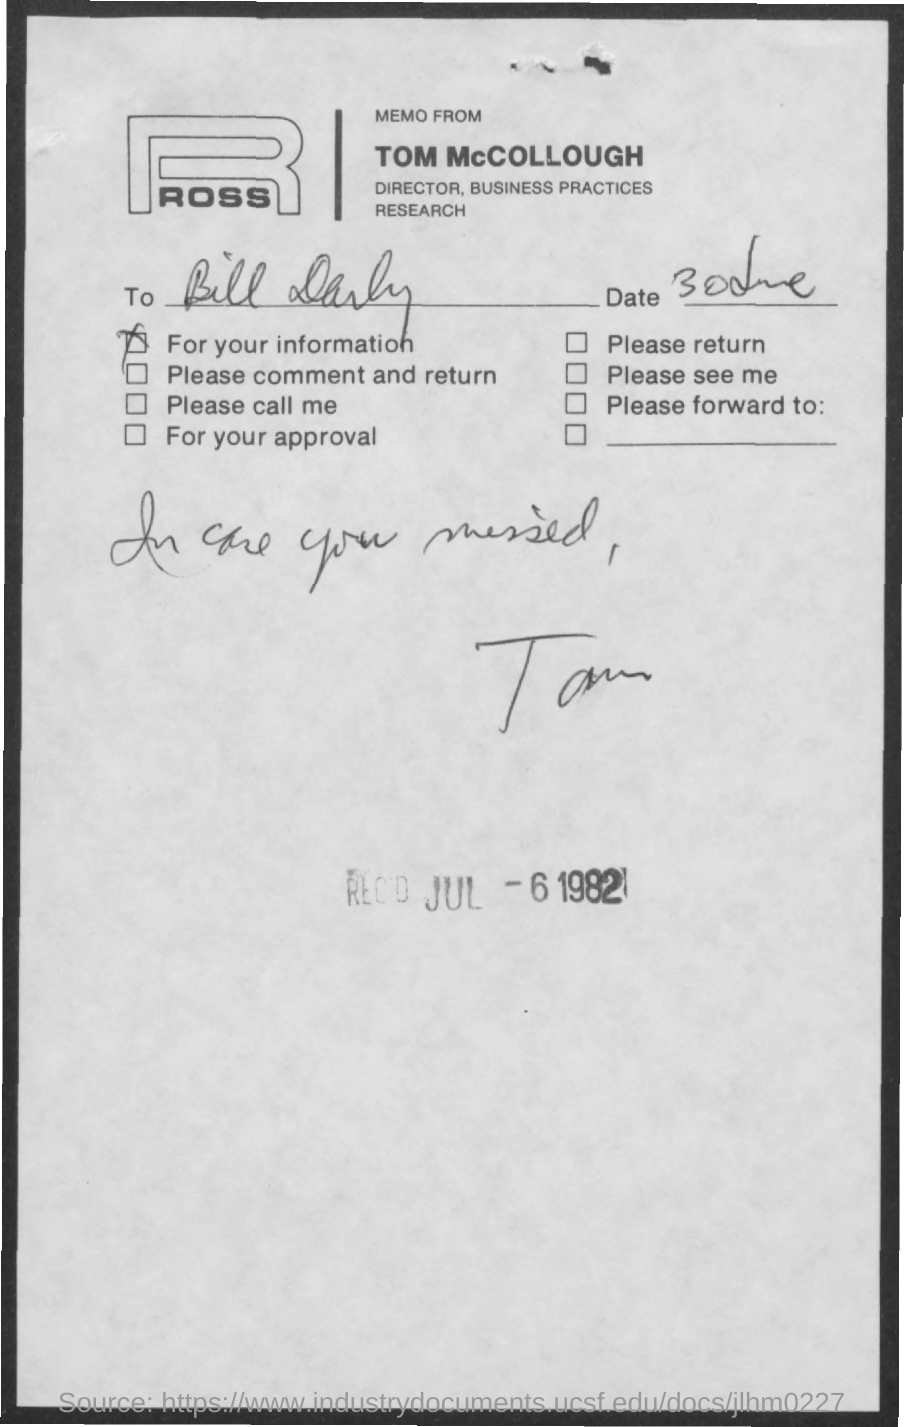List a handful of essential elements in this visual. The memo is addressed to Bill Darby. Tom McColloch is the director of Business Practices Research. The sender of this memo is Tom McColloch. On July 6, 1982, the received date stamp was observed. 